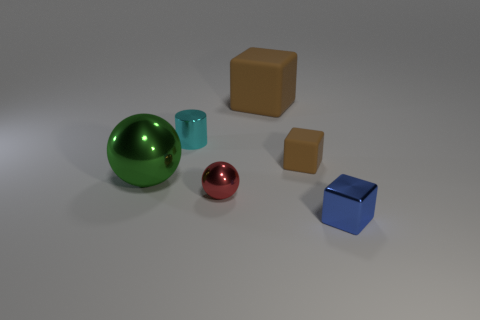There is another block that is the same color as the big rubber cube; what is its size?
Provide a short and direct response. Small. What number of things are large rubber objects or brown rubber things that are right of the big metal object?
Your answer should be compact. 2. Are there any small blue blocks made of the same material as the blue thing?
Keep it short and to the point. No. What number of tiny metal objects are to the right of the tiny cyan metallic cylinder and behind the tiny blue block?
Keep it short and to the point. 1. What is the brown object behind the tiny brown cube made of?
Your response must be concise. Rubber. There is a sphere that is made of the same material as the red object; what is its size?
Offer a very short reply. Large. There is a large matte object; are there any large rubber blocks right of it?
Keep it short and to the point. No. What is the size of the other matte thing that is the same shape as the large brown rubber thing?
Provide a short and direct response. Small. There is a small ball; is it the same color as the cube that is in front of the large green shiny thing?
Your answer should be compact. No. Is the color of the cylinder the same as the large metal thing?
Your answer should be very brief. No. 